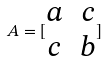<formula> <loc_0><loc_0><loc_500><loc_500>A = [ \begin{matrix} a & c \\ c & b \end{matrix} ]</formula> 